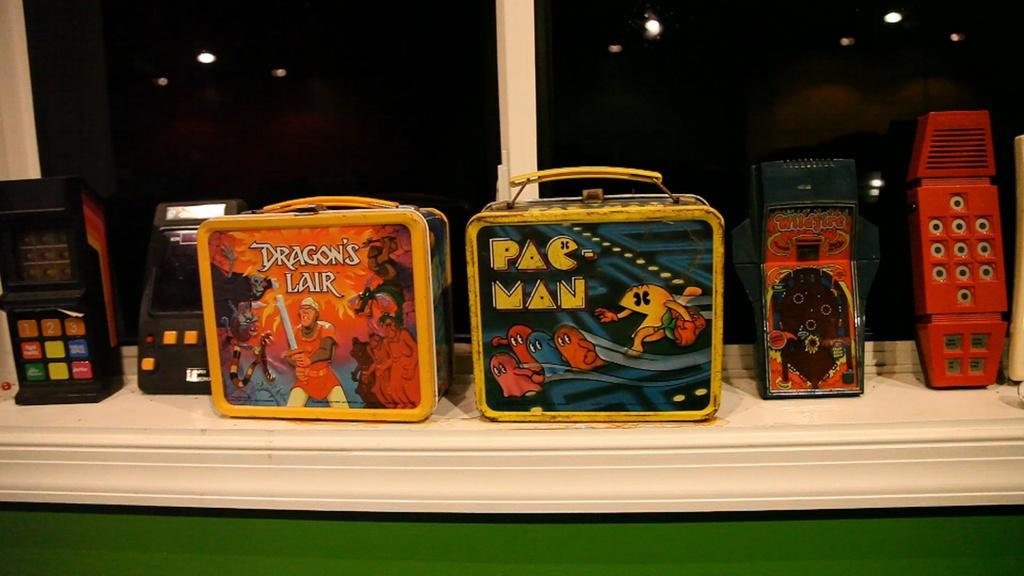What type of items are visible in the image? There are gadgets and boxes in the image. Where are the gadgets and boxes located? The gadgets and boxes are in front of a window. How does the person in the image care for their watch while sitting on the edge? There is no person, watch, or edge present in the image; it only features gadgets and boxes in front of a window. 